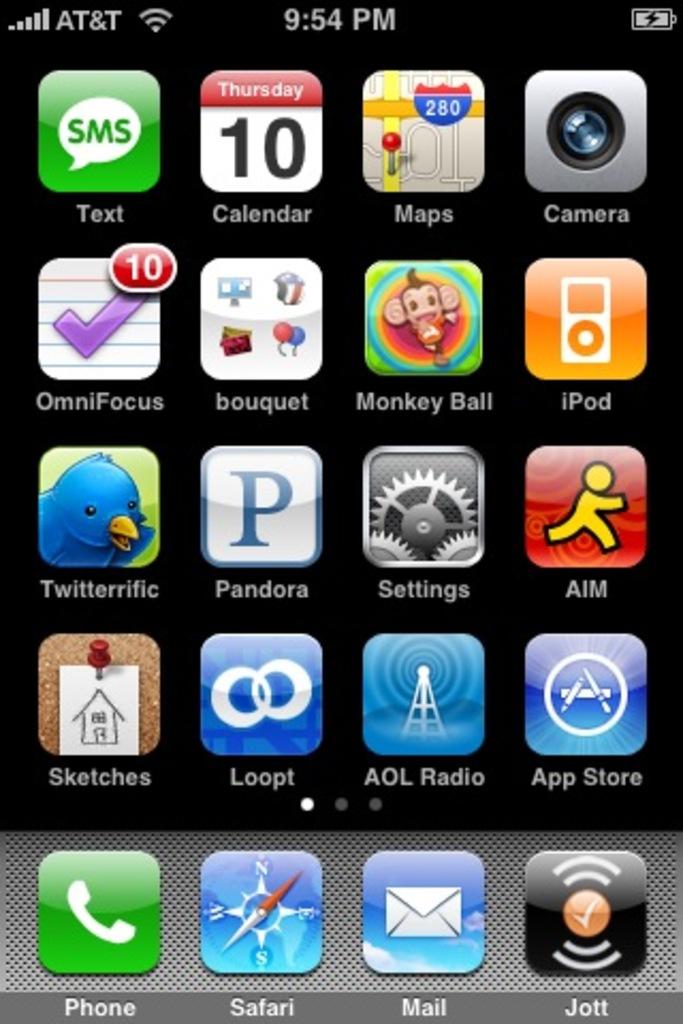What network is this person on?
Your answer should be compact. At&t. 